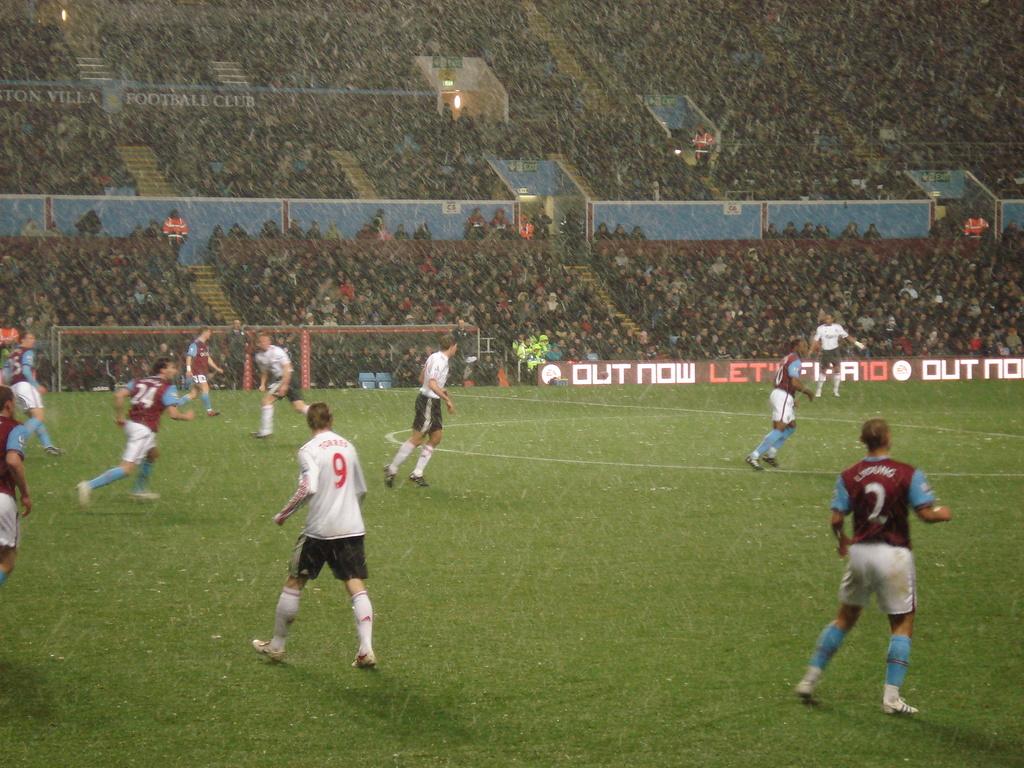What number is on the man in whites jersey?
Your answer should be very brief. 9. 